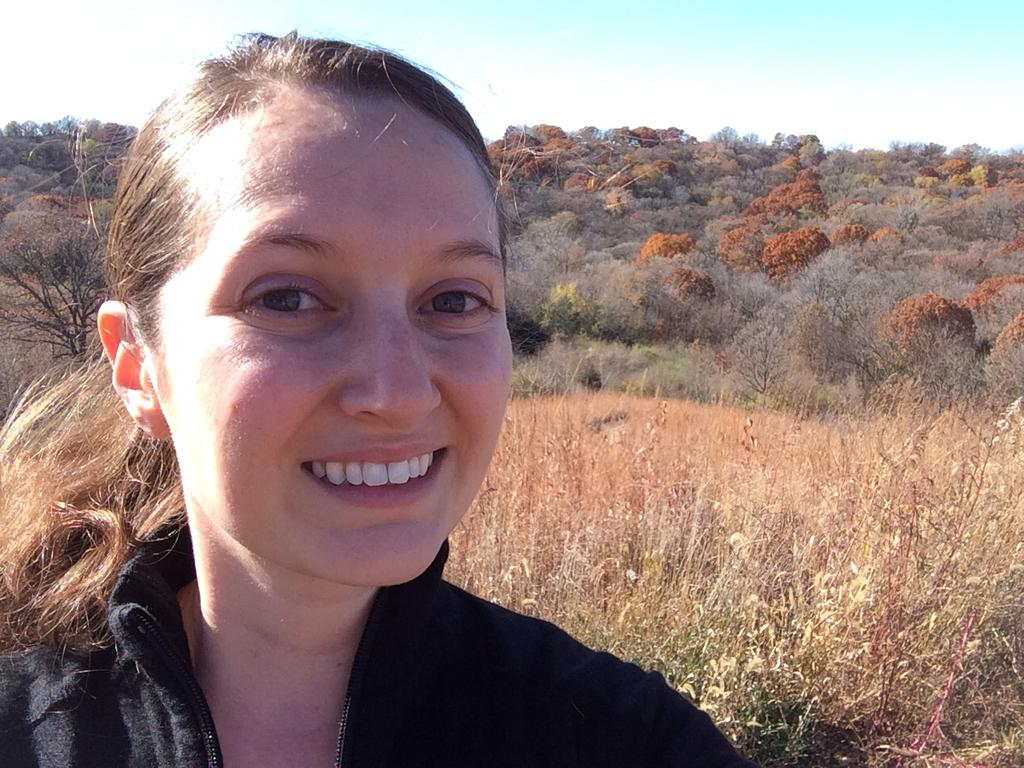Who is present in the image? There is a woman in the image. What is the woman's facial expression? The woman is smiling. What can be seen in the background of the image? There are trees visible in the background of the image. What is visible at the top of the image? The sky is visible at the top of the image. What is located at the bottom of the image? There are plants at the bottom of the image. How many dogs are attached to the woman's chain in the image? There are no dogs or chains present in the image. What type of zipper is visible on the woman's clothing in the image? There is no zipper visible on the woman's clothing in the image. 